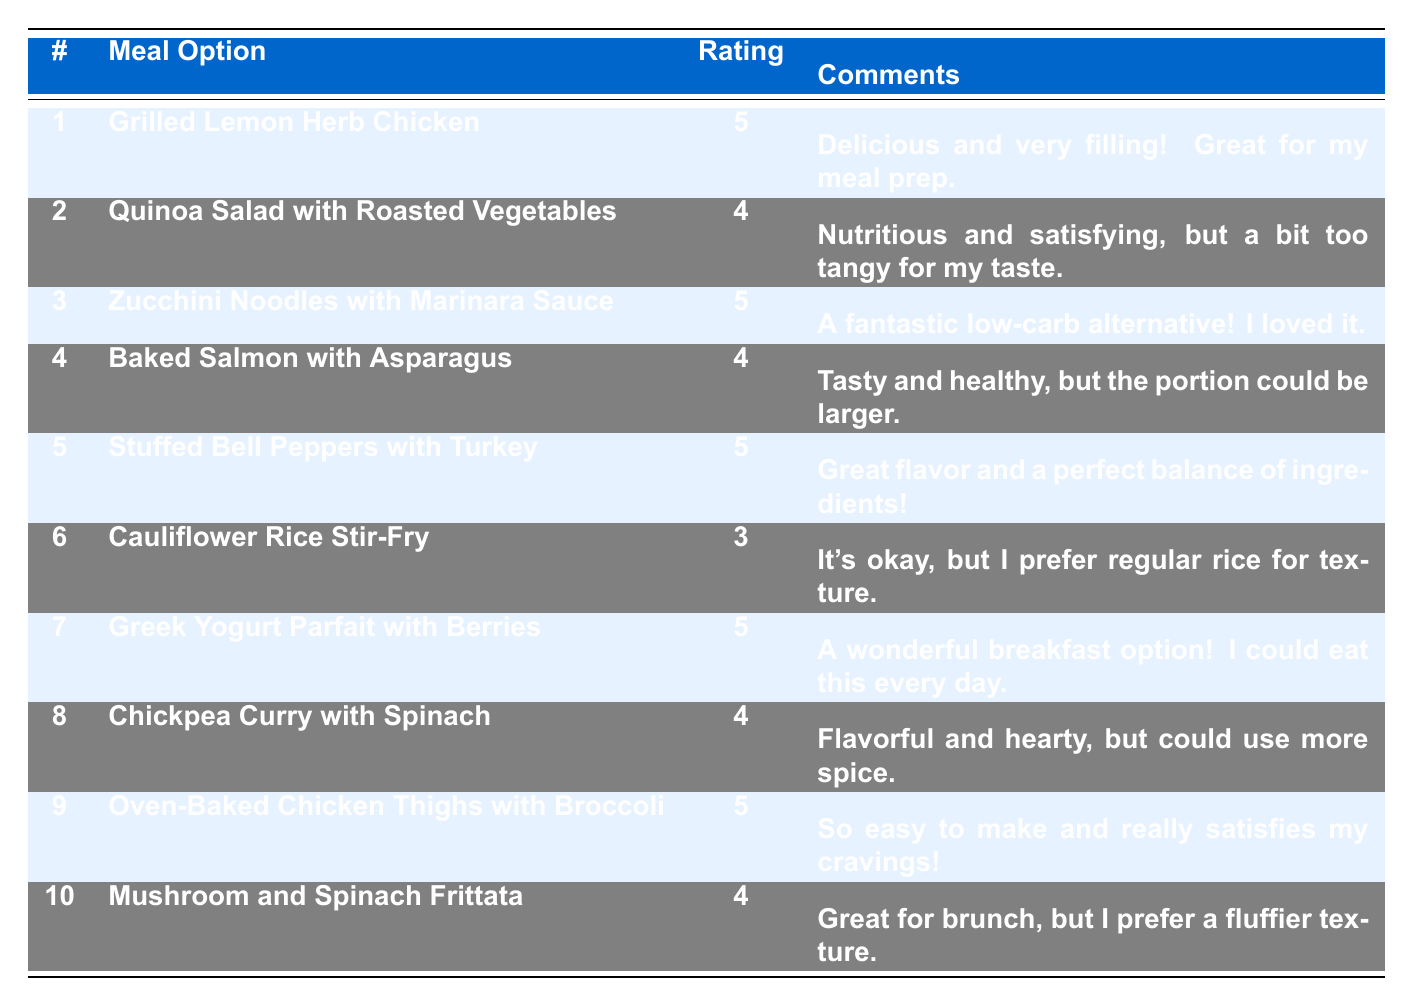What meal option received the highest rating? The meal options with the highest rating of 5 are Grilled Lemon Herb Chicken, Zucchini Noodles with Marinara Sauce, Stuffed Bell Peppers with Turkey, Greek Yogurt Parfait with Berries, and Oven-Baked Chicken Thighs with Broccoli.
Answer: Grilled Lemon Herb Chicken, Zucchini Noodles with Marinara Sauce, Stuffed Bell Peppers with Turkey, Greek Yogurt Parfait with Berries, Oven-Baked Chicken Thighs with Broccoli Which member provided feedback on the Quinoa Salad with Roasted Vegetables? The member who provided feedback on the Quinoa Salad with Roasted Vegetables is Maria Garcia.
Answer: Maria Garcia How many meal options received a rating of 4? From the table, there are 4 meal options that received a rating of 4: Quinoa Salad with Roasted Vegetables, Baked Salmon with Asparagus, Chickpea Curry with Spinach, and Mushroom and Spinach Frittata.
Answer: 4 What is the average rating of all meal options? To find the average rating, sum all the ratings: (5 + 4 + 5 + 4 + 5 + 3 + 5 + 4 + 5 + 4) =  53. Then, divide by the number of meal options (10). Therefore, the average rating is 53 / 10 = 5.3.
Answer: 5.3 Did any meal options receive a rating of 3? Yes, one meal option, Cauliflower Rice Stir-Fry, received a rating of 3.
Answer: Yes Which is the only meal option rated 3, and who commented on it? The only meal option rated 3 is Cauliflower Rice Stir-Fry, and Robert Brown commented on it.
Answer: Cauliflower Rice Stir-Fry, Robert Brown Which meal option had the most comments about portion size? The Baked Salmon with Asparagus received a comment regarding portion size, stating that "the portion could be larger."
Answer: Baked Salmon with Asparagus What percentage of meal options received a rating of 5? There are 5 meal options with a rating of 5 out of a total of 10 meal options. To calculate the percentage, (5 / 10) * 100 = 50%.
Answer: 50% Is there a meal option that is suggested as a great breakfast option? Yes, Greek Yogurt Parfait with Berries is suggested as a great breakfast option according to the comment.
Answer: Yes What is the total number of ratings provided, and how many of them are positive (i.e., ratings of 4 or 5)? There are 10 ratings in total. The positive ratings are 5 (5 ratings) and 4 (4 ratings), which sum to 9 positive ratings.
Answer: 9 positive ratings 